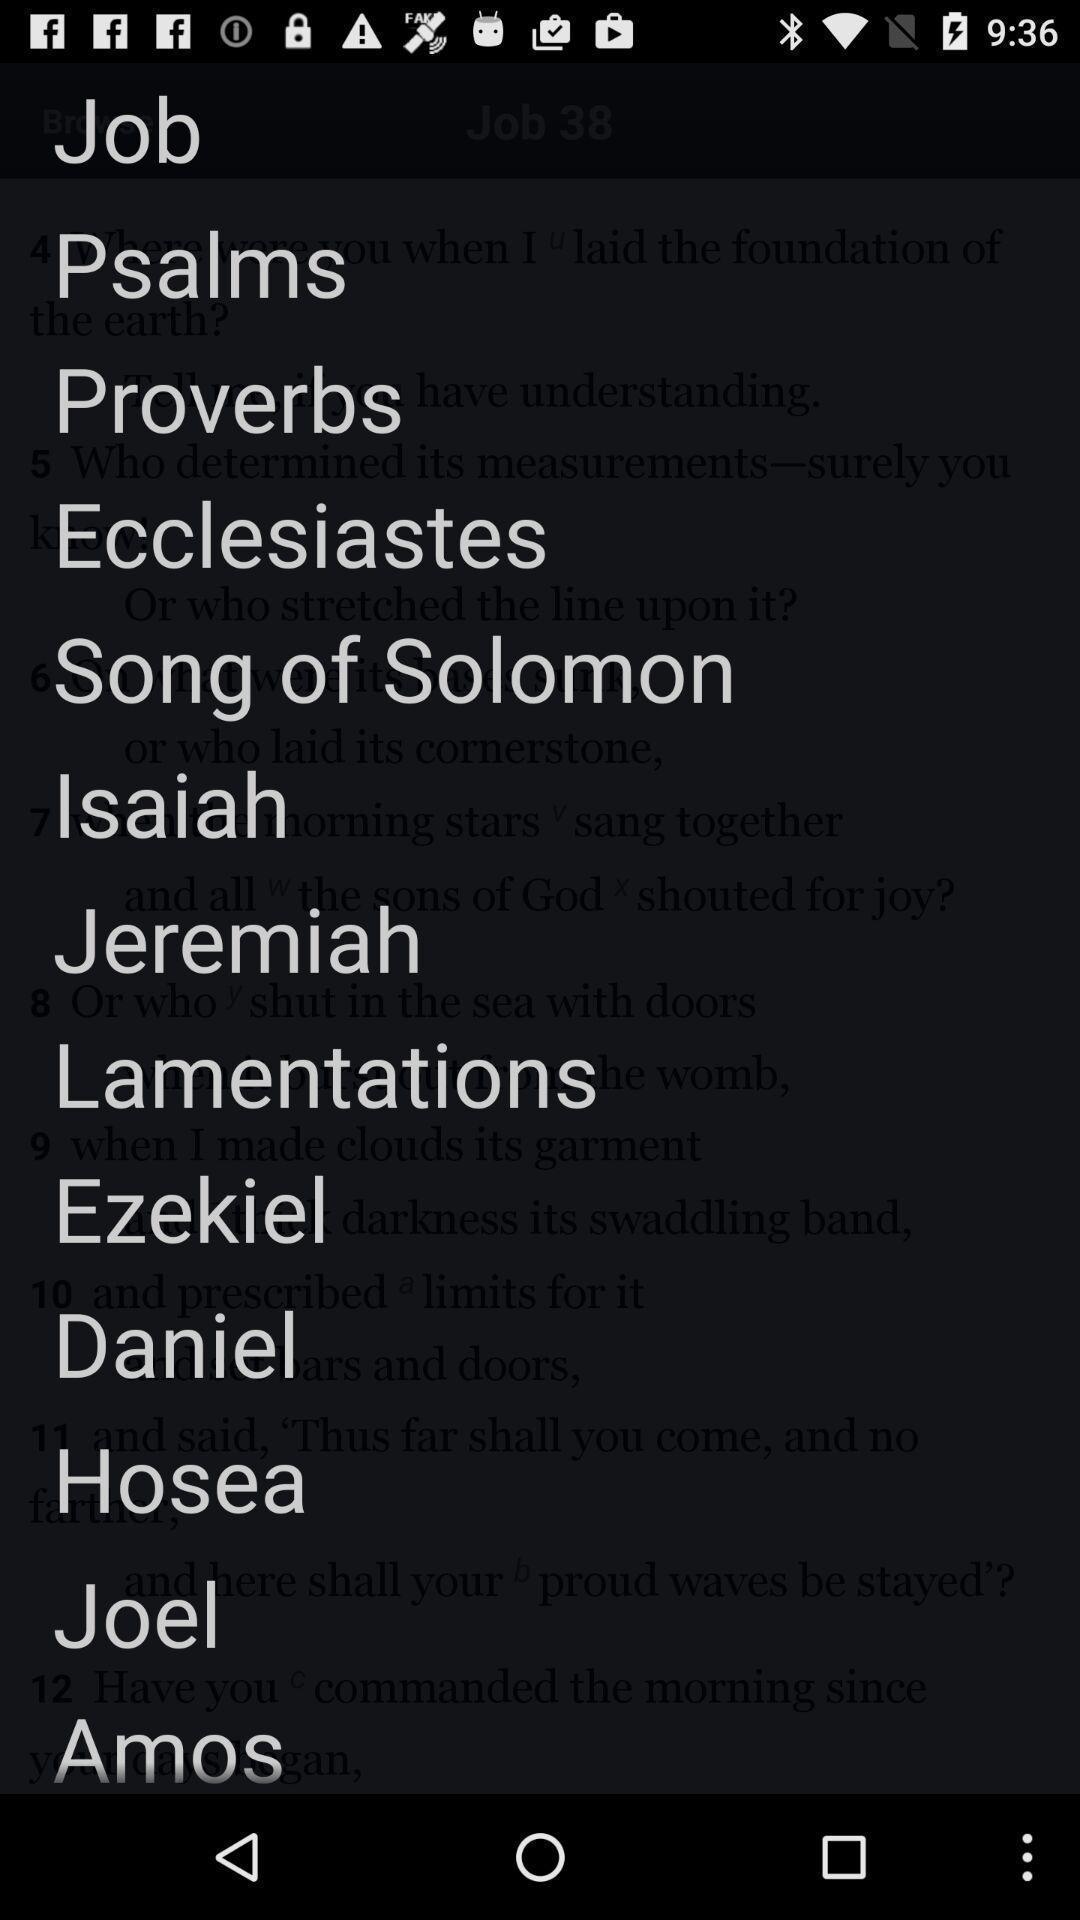Explain what's happening in this screen capture. Page of a holy book app showing list of topics. 